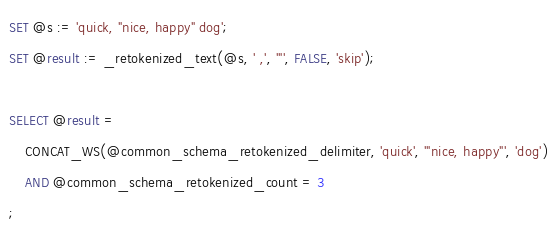Convert code to text. <code><loc_0><loc_0><loc_500><loc_500><_SQL_>SET @s := 'quick, "nice, happy" dog';
SET @result := _retokenized_text(@s, ' ,', '"', FALSE, 'skip');

SELECT @result = 
    CONCAT_WS(@common_schema_retokenized_delimiter, 'quick', '"nice, happy"', 'dog')
    AND @common_schema_retokenized_count = 3
;
</code> 